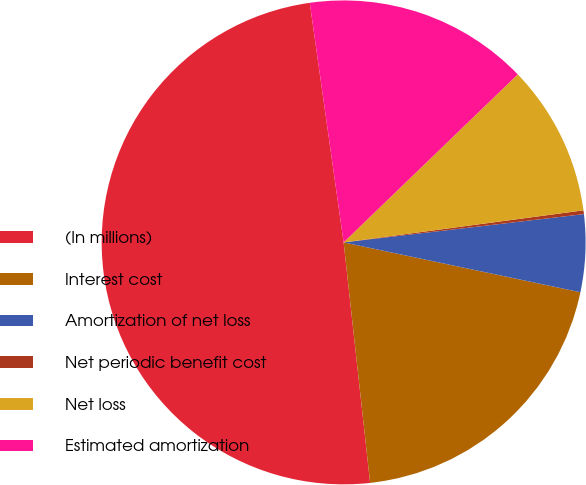<chart> <loc_0><loc_0><loc_500><loc_500><pie_chart><fcel>(In millions)<fcel>Interest cost<fcel>Amortization of net loss<fcel>Net periodic benefit cost<fcel>Net loss<fcel>Estimated amortization<nl><fcel>49.51%<fcel>19.95%<fcel>5.17%<fcel>0.25%<fcel>10.1%<fcel>15.02%<nl></chart> 